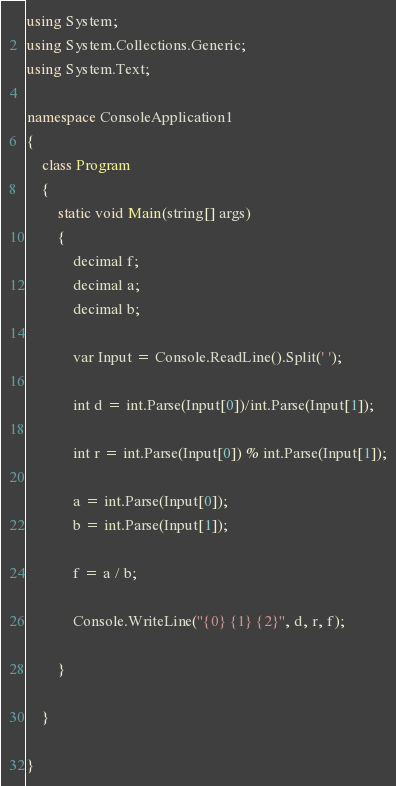<code> <loc_0><loc_0><loc_500><loc_500><_C#_>using System;
using System.Collections.Generic;
using System.Text;

namespace ConsoleApplication1
{
    class Program
    {
        static void Main(string[] args)
        {
            decimal f;
            decimal a;
            decimal b;

            var Input = Console.ReadLine().Split(' ');

            int d = int.Parse(Input[0])/int.Parse(Input[1]);

            int r = int.Parse(Input[0]) % int.Parse(Input[1]);

            a = int.Parse(Input[0]);
            b = int.Parse(Input[1]);
       
            f = a / b;

            Console.WriteLine("{0} {1} {2}", d, r, f);

        }

    }

}</code> 